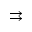<formula> <loc_0><loc_0><loc_500><loc_500>\right r i g h t a r r o w s</formula> 